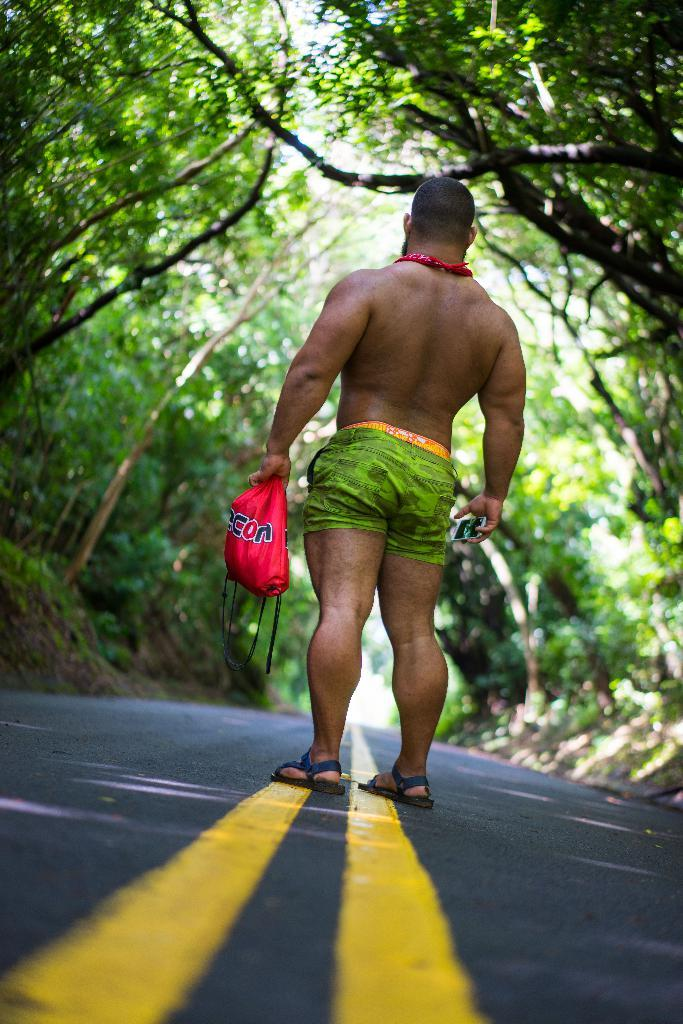What is the main subject of the image? There is a man in the image. What is the man doing in the image? The man is standing on the ground. What is the man holding in each hand? The man is holding a polythene cover in one hand and a mobile phone in the other hand. What can be seen in the background of the image? There are trees and sand visible in the background of the image. Can you see any underwear hanging on the trees in the image? There is no underwear visible in the image; the background elements are trees and sand. 